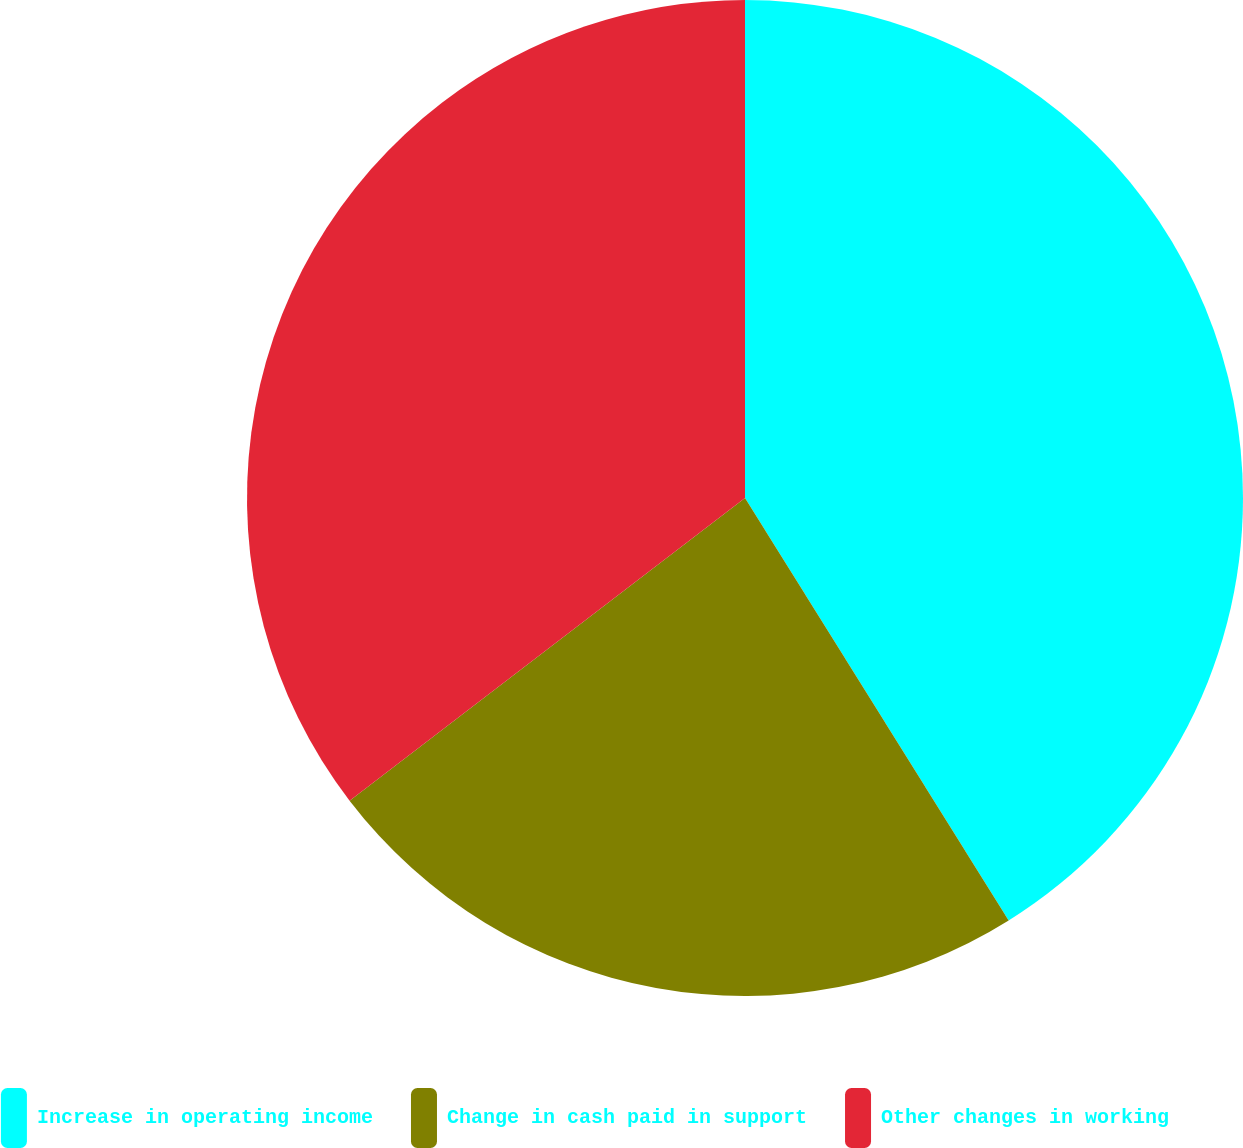Convert chart. <chart><loc_0><loc_0><loc_500><loc_500><pie_chart><fcel>Increase in operating income<fcel>Change in cash paid in support<fcel>Other changes in working<nl><fcel>41.12%<fcel>23.48%<fcel>35.4%<nl></chart> 